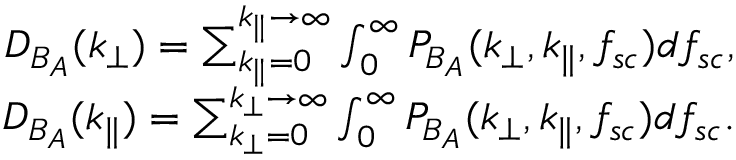<formula> <loc_0><loc_0><loc_500><loc_500>\begin{array} { r } { D _ { B _ { A } } ( k _ { \perp } ) = \sum _ { k _ { \| } = 0 } ^ { k _ { \| } \rightarrow \infty } \int _ { 0 } ^ { \infty } P _ { B _ { A } } ( k _ { \perp } , k _ { \| } , f _ { s c } ) d f _ { s c } , } \\ { D _ { B _ { A } } ( k _ { \| } ) = \sum _ { k _ { \perp } = 0 } ^ { k _ { \perp } \rightarrow \infty } \int _ { 0 } ^ { \infty } P _ { B _ { A } } ( k _ { \perp } , k _ { \| } , f _ { s c } ) d f _ { s c } . } \end{array}</formula> 